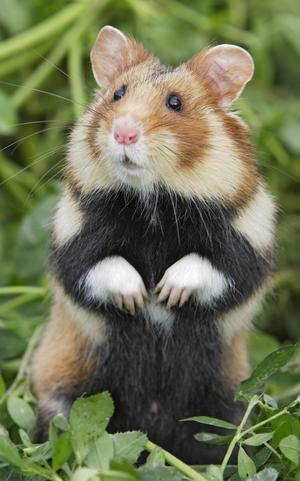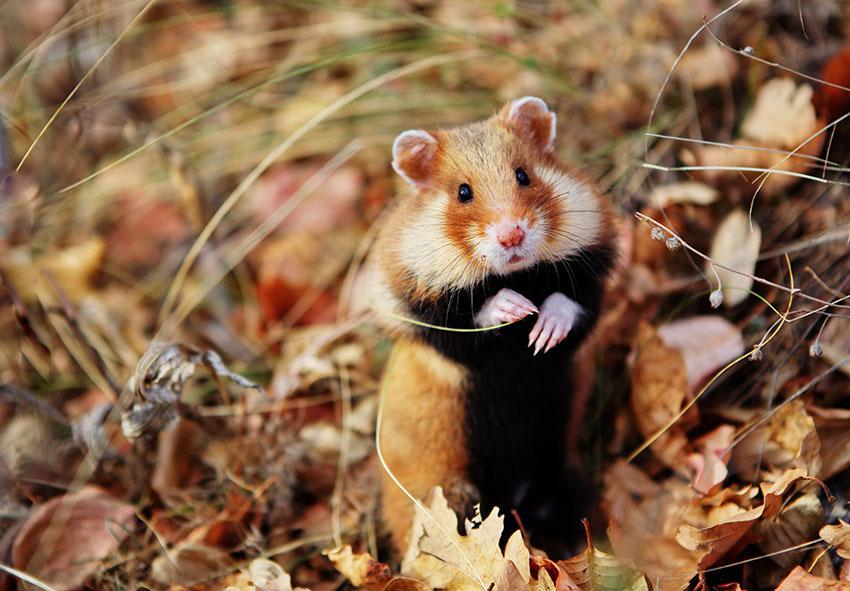The first image is the image on the left, the second image is the image on the right. Considering the images on both sides, is "in one image a hamster with a black stomach is standing in grass and looking to the left" valid? Answer yes or no. Yes. 